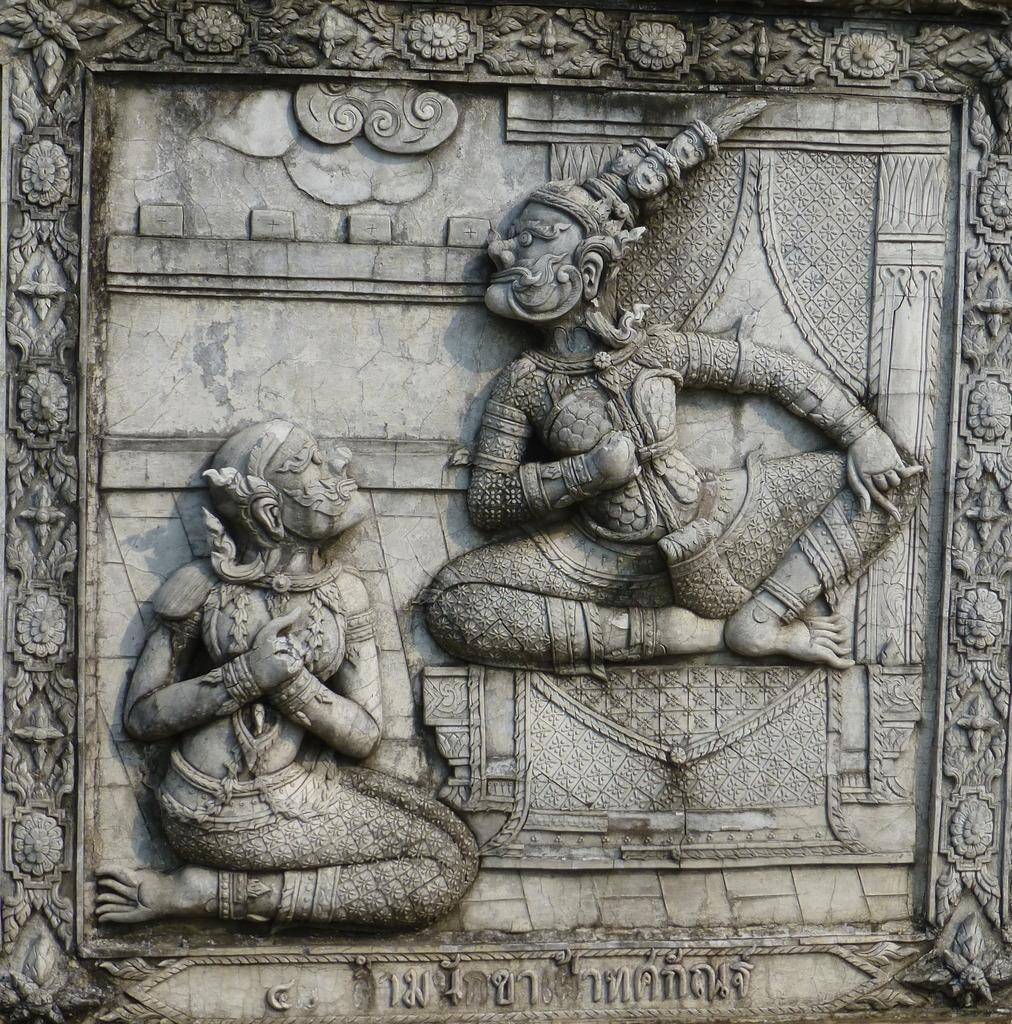What is present on the wall in the image? There are sculptures on the wall in the image. What type of orange can be seen growing on the seashore in the image? There is no orange or seashore present in the image. 